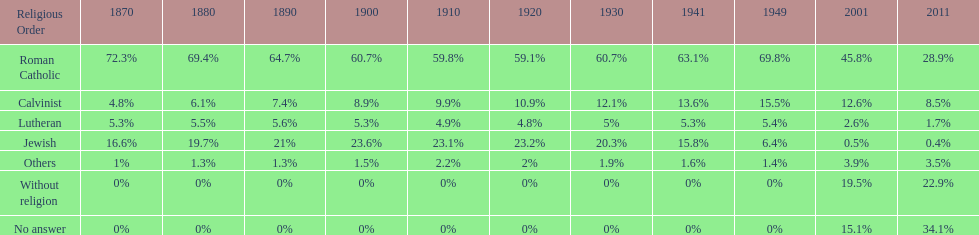In which year was the percentage of those without religion at least 20%? 2011. 